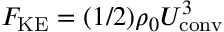Convert formula to latex. <formula><loc_0><loc_0><loc_500><loc_500>F _ { K E } = ( 1 / 2 ) \rho _ { 0 } U _ { c o n v } ^ { 3 }</formula> 